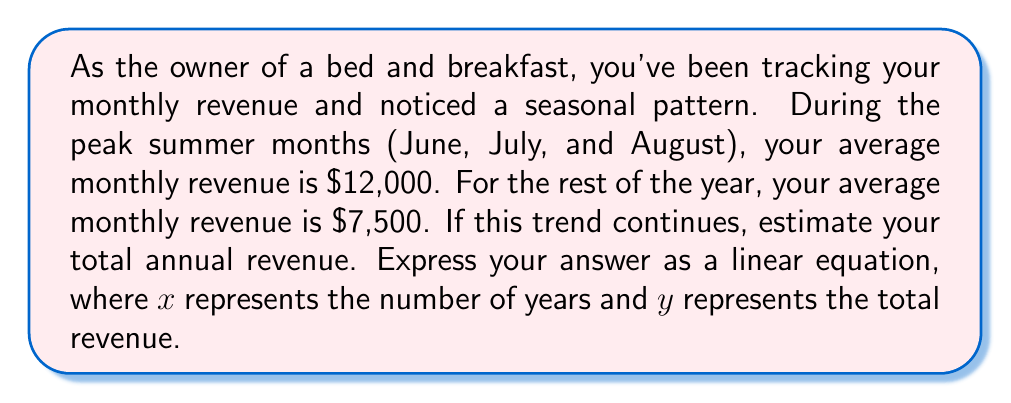Can you answer this question? To solve this problem, let's break it down into steps:

1. Calculate the revenue for peak months:
   $3 \text{ months} \times \$12,000 = \$36,000$

2. Calculate the revenue for non-peak months:
   $9 \text{ months} \times \$7,500 = \$67,500$

3. Calculate the total annual revenue:
   $\$36,000 + \$67,500 = \$103,500$

4. Express this as a linear equation:
   Since the question asks for a linear equation where $x$ represents the number of years and $y$ represents the total revenue, we can write:

   $$y = 103500x$$

   This equation means that for each year ($x$), the total revenue ($y$) will be $103,500 multiplied by the number of years.

5. Verify the equation:
   For 1 year: $y = 103500(1) = 103500$
   For 2 years: $y = 103500(2) = 207000$
   
   This shows that the revenue doubles every year, assuming the seasonal trend remains constant.
Answer: $$y = 103500x$$ 